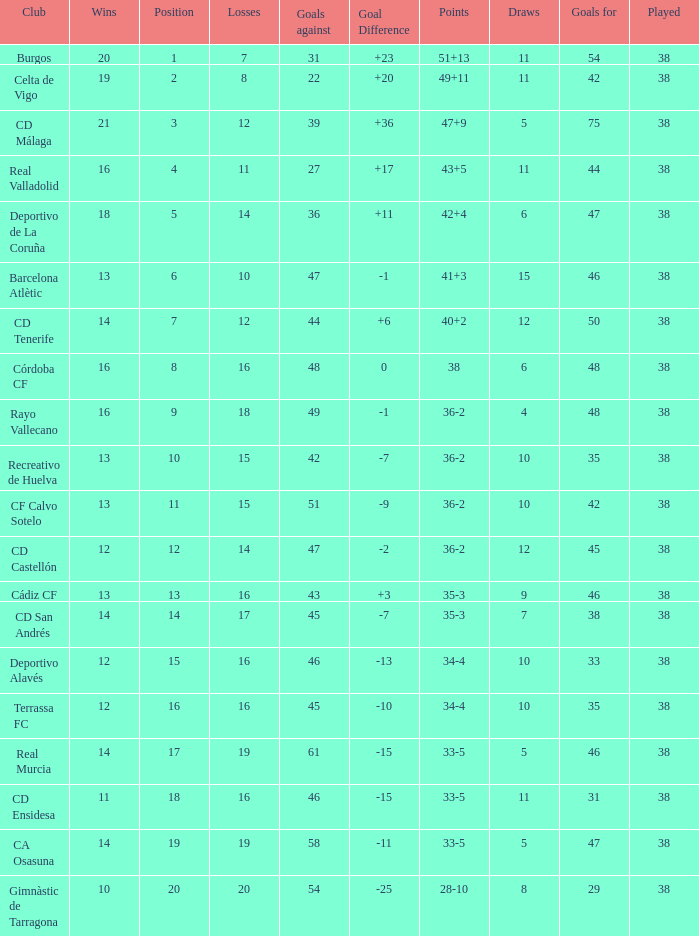What is the average loss with a goal higher than 51 and wins higher than 14? None. 